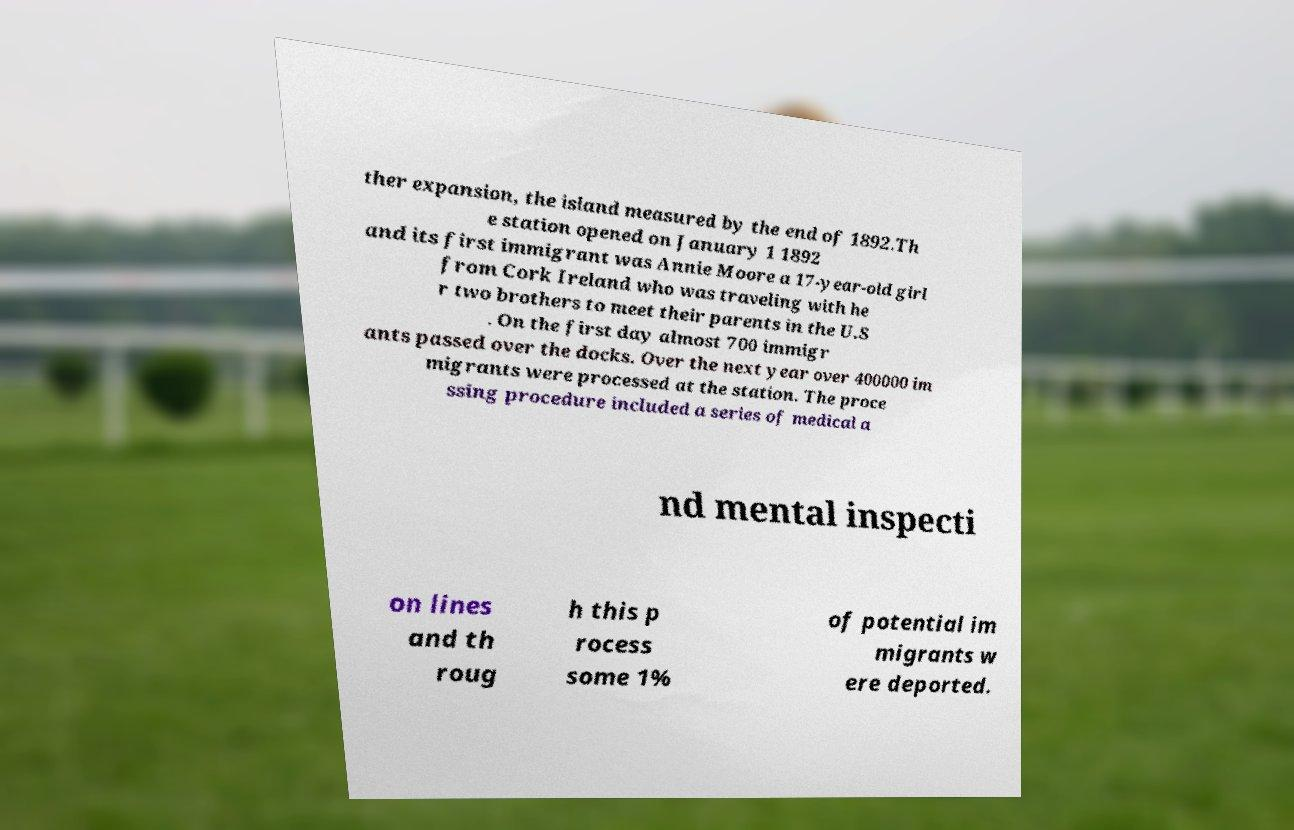What messages or text are displayed in this image? I need them in a readable, typed format. ther expansion, the island measured by the end of 1892.Th e station opened on January 1 1892 and its first immigrant was Annie Moore a 17-year-old girl from Cork Ireland who was traveling with he r two brothers to meet their parents in the U.S . On the first day almost 700 immigr ants passed over the docks. Over the next year over 400000 im migrants were processed at the station. The proce ssing procedure included a series of medical a nd mental inspecti on lines and th roug h this p rocess some 1% of potential im migrants w ere deported. 